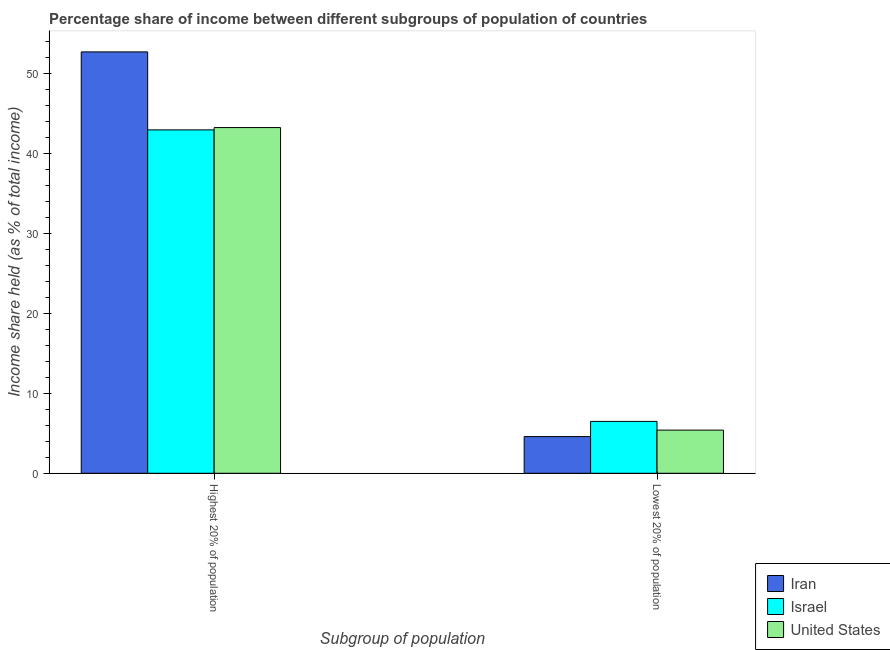How many bars are there on the 1st tick from the left?
Provide a succinct answer. 3. What is the label of the 1st group of bars from the left?
Offer a terse response. Highest 20% of population. What is the income share held by highest 20% of the population in United States?
Make the answer very short. 43.26. Across all countries, what is the maximum income share held by lowest 20% of the population?
Ensure brevity in your answer.  6.49. Across all countries, what is the minimum income share held by lowest 20% of the population?
Keep it short and to the point. 4.59. In which country was the income share held by lowest 20% of the population maximum?
Offer a very short reply. Israel. In which country was the income share held by lowest 20% of the population minimum?
Ensure brevity in your answer.  Iran. What is the total income share held by lowest 20% of the population in the graph?
Ensure brevity in your answer.  16.48. What is the difference between the income share held by highest 20% of the population in Iran and that in Israel?
Your response must be concise. 9.76. What is the difference between the income share held by highest 20% of the population in United States and the income share held by lowest 20% of the population in Israel?
Make the answer very short. 36.77. What is the average income share held by highest 20% of the population per country?
Provide a succinct answer. 46.32. What is the difference between the income share held by highest 20% of the population and income share held by lowest 20% of the population in Israel?
Provide a succinct answer. 36.48. What is the ratio of the income share held by lowest 20% of the population in Iran to that in United States?
Your response must be concise. 0.85. What does the 3rd bar from the left in Lowest 20% of population represents?
Make the answer very short. United States. What does the 3rd bar from the right in Highest 20% of population represents?
Ensure brevity in your answer.  Iran. Are all the bars in the graph horizontal?
Give a very brief answer. No. How many countries are there in the graph?
Keep it short and to the point. 3. Are the values on the major ticks of Y-axis written in scientific E-notation?
Your answer should be very brief. No. Does the graph contain any zero values?
Your response must be concise. No. Where does the legend appear in the graph?
Provide a short and direct response. Bottom right. How many legend labels are there?
Offer a very short reply. 3. How are the legend labels stacked?
Your answer should be compact. Vertical. What is the title of the graph?
Provide a succinct answer. Percentage share of income between different subgroups of population of countries. Does "Mauritania" appear as one of the legend labels in the graph?
Make the answer very short. No. What is the label or title of the X-axis?
Provide a short and direct response. Subgroup of population. What is the label or title of the Y-axis?
Your response must be concise. Income share held (as % of total income). What is the Income share held (as % of total income) of Iran in Highest 20% of population?
Ensure brevity in your answer.  52.73. What is the Income share held (as % of total income) in Israel in Highest 20% of population?
Make the answer very short. 42.97. What is the Income share held (as % of total income) of United States in Highest 20% of population?
Provide a short and direct response. 43.26. What is the Income share held (as % of total income) of Iran in Lowest 20% of population?
Your answer should be compact. 4.59. What is the Income share held (as % of total income) in Israel in Lowest 20% of population?
Your response must be concise. 6.49. What is the Income share held (as % of total income) in United States in Lowest 20% of population?
Your answer should be very brief. 5.4. Across all Subgroup of population, what is the maximum Income share held (as % of total income) of Iran?
Offer a very short reply. 52.73. Across all Subgroup of population, what is the maximum Income share held (as % of total income) in Israel?
Give a very brief answer. 42.97. Across all Subgroup of population, what is the maximum Income share held (as % of total income) of United States?
Keep it short and to the point. 43.26. Across all Subgroup of population, what is the minimum Income share held (as % of total income) in Iran?
Ensure brevity in your answer.  4.59. Across all Subgroup of population, what is the minimum Income share held (as % of total income) in Israel?
Your response must be concise. 6.49. What is the total Income share held (as % of total income) of Iran in the graph?
Offer a terse response. 57.32. What is the total Income share held (as % of total income) in Israel in the graph?
Provide a succinct answer. 49.46. What is the total Income share held (as % of total income) of United States in the graph?
Your answer should be compact. 48.66. What is the difference between the Income share held (as % of total income) of Iran in Highest 20% of population and that in Lowest 20% of population?
Give a very brief answer. 48.14. What is the difference between the Income share held (as % of total income) in Israel in Highest 20% of population and that in Lowest 20% of population?
Offer a terse response. 36.48. What is the difference between the Income share held (as % of total income) of United States in Highest 20% of population and that in Lowest 20% of population?
Give a very brief answer. 37.86. What is the difference between the Income share held (as % of total income) in Iran in Highest 20% of population and the Income share held (as % of total income) in Israel in Lowest 20% of population?
Your answer should be very brief. 46.24. What is the difference between the Income share held (as % of total income) of Iran in Highest 20% of population and the Income share held (as % of total income) of United States in Lowest 20% of population?
Give a very brief answer. 47.33. What is the difference between the Income share held (as % of total income) of Israel in Highest 20% of population and the Income share held (as % of total income) of United States in Lowest 20% of population?
Keep it short and to the point. 37.57. What is the average Income share held (as % of total income) in Iran per Subgroup of population?
Ensure brevity in your answer.  28.66. What is the average Income share held (as % of total income) of Israel per Subgroup of population?
Your response must be concise. 24.73. What is the average Income share held (as % of total income) in United States per Subgroup of population?
Offer a very short reply. 24.33. What is the difference between the Income share held (as % of total income) in Iran and Income share held (as % of total income) in Israel in Highest 20% of population?
Keep it short and to the point. 9.76. What is the difference between the Income share held (as % of total income) in Iran and Income share held (as % of total income) in United States in Highest 20% of population?
Give a very brief answer. 9.47. What is the difference between the Income share held (as % of total income) of Israel and Income share held (as % of total income) of United States in Highest 20% of population?
Give a very brief answer. -0.29. What is the difference between the Income share held (as % of total income) in Iran and Income share held (as % of total income) in Israel in Lowest 20% of population?
Offer a terse response. -1.9. What is the difference between the Income share held (as % of total income) of Iran and Income share held (as % of total income) of United States in Lowest 20% of population?
Ensure brevity in your answer.  -0.81. What is the difference between the Income share held (as % of total income) in Israel and Income share held (as % of total income) in United States in Lowest 20% of population?
Your answer should be very brief. 1.09. What is the ratio of the Income share held (as % of total income) in Iran in Highest 20% of population to that in Lowest 20% of population?
Keep it short and to the point. 11.49. What is the ratio of the Income share held (as % of total income) in Israel in Highest 20% of population to that in Lowest 20% of population?
Provide a succinct answer. 6.62. What is the ratio of the Income share held (as % of total income) of United States in Highest 20% of population to that in Lowest 20% of population?
Keep it short and to the point. 8.01. What is the difference between the highest and the second highest Income share held (as % of total income) in Iran?
Give a very brief answer. 48.14. What is the difference between the highest and the second highest Income share held (as % of total income) of Israel?
Offer a terse response. 36.48. What is the difference between the highest and the second highest Income share held (as % of total income) of United States?
Offer a very short reply. 37.86. What is the difference between the highest and the lowest Income share held (as % of total income) in Iran?
Provide a succinct answer. 48.14. What is the difference between the highest and the lowest Income share held (as % of total income) of Israel?
Give a very brief answer. 36.48. What is the difference between the highest and the lowest Income share held (as % of total income) in United States?
Your answer should be very brief. 37.86. 